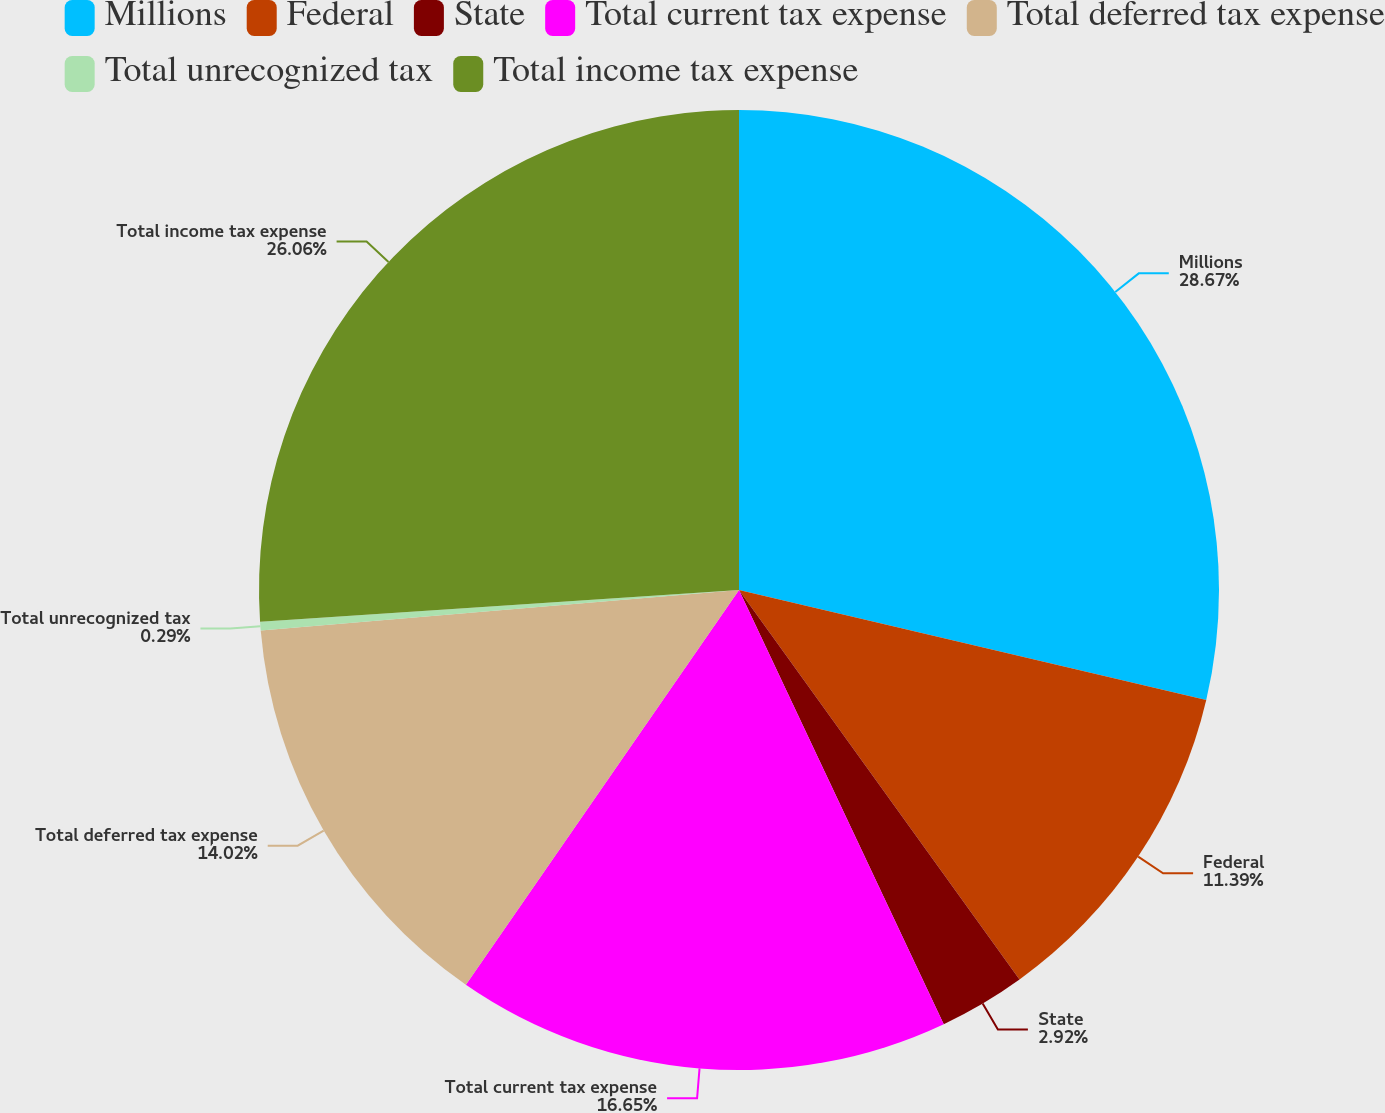Convert chart to OTSL. <chart><loc_0><loc_0><loc_500><loc_500><pie_chart><fcel>Millions<fcel>Federal<fcel>State<fcel>Total current tax expense<fcel>Total deferred tax expense<fcel>Total unrecognized tax<fcel>Total income tax expense<nl><fcel>28.68%<fcel>11.39%<fcel>2.92%<fcel>16.65%<fcel>14.02%<fcel>0.29%<fcel>26.06%<nl></chart> 